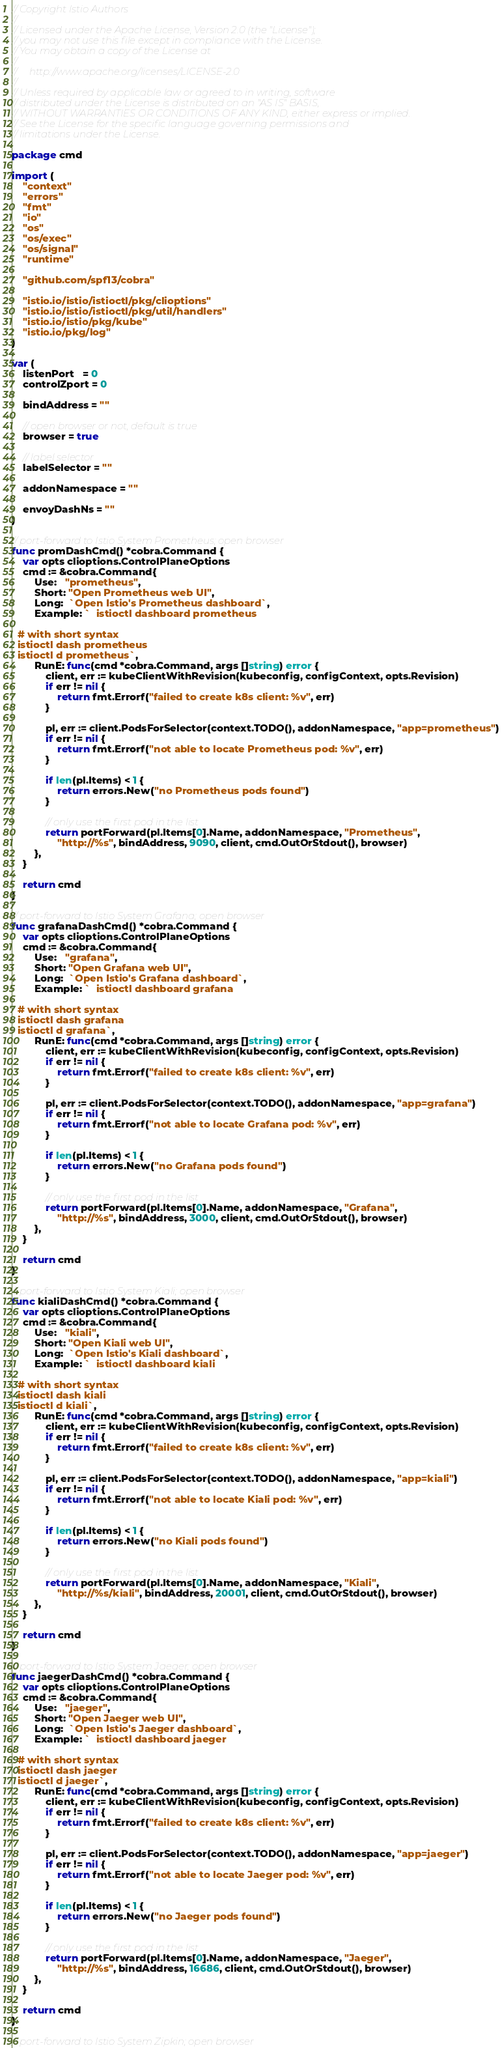<code> <loc_0><loc_0><loc_500><loc_500><_Go_>// Copyright Istio Authors
//
// Licensed under the Apache License, Version 2.0 (the "License");
// you may not use this file except in compliance with the License.
// You may obtain a copy of the License at
//
//     http://www.apache.org/licenses/LICENSE-2.0
//
// Unless required by applicable law or agreed to in writing, software
// distributed under the License is distributed on an "AS IS" BASIS,
// WITHOUT WARRANTIES OR CONDITIONS OF ANY KIND, either express or implied.
// See the License for the specific language governing permissions and
// limitations under the License.

package cmd

import (
	"context"
	"errors"
	"fmt"
	"io"
	"os"
	"os/exec"
	"os/signal"
	"runtime"

	"github.com/spf13/cobra"

	"istio.io/istio/istioctl/pkg/clioptions"
	"istio.io/istio/istioctl/pkg/util/handlers"
	"istio.io/istio/pkg/kube"
	"istio.io/pkg/log"
)

var (
	listenPort   = 0
	controlZport = 0

	bindAddress = ""

	// open browser or not, default is true
	browser = true

	// label selector
	labelSelector = ""

	addonNamespace = ""

	envoyDashNs = ""
)

// port-forward to Istio System Prometheus; open browser
func promDashCmd() *cobra.Command {
	var opts clioptions.ControlPlaneOptions
	cmd := &cobra.Command{
		Use:   "prometheus",
		Short: "Open Prometheus web UI",
		Long:  `Open Istio's Prometheus dashboard`,
		Example: `  istioctl dashboard prometheus

  # with short syntax
  istioctl dash prometheus
  istioctl d prometheus`,
		RunE: func(cmd *cobra.Command, args []string) error {
			client, err := kubeClientWithRevision(kubeconfig, configContext, opts.Revision)
			if err != nil {
				return fmt.Errorf("failed to create k8s client: %v", err)
			}

			pl, err := client.PodsForSelector(context.TODO(), addonNamespace, "app=prometheus")
			if err != nil {
				return fmt.Errorf("not able to locate Prometheus pod: %v", err)
			}

			if len(pl.Items) < 1 {
				return errors.New("no Prometheus pods found")
			}

			// only use the first pod in the list
			return portForward(pl.Items[0].Name, addonNamespace, "Prometheus",
				"http://%s", bindAddress, 9090, client, cmd.OutOrStdout(), browser)
		},
	}

	return cmd
}

// port-forward to Istio System Grafana; open browser
func grafanaDashCmd() *cobra.Command {
	var opts clioptions.ControlPlaneOptions
	cmd := &cobra.Command{
		Use:   "grafana",
		Short: "Open Grafana web UI",
		Long:  `Open Istio's Grafana dashboard`,
		Example: `  istioctl dashboard grafana

  # with short syntax
  istioctl dash grafana
  istioctl d grafana`,
		RunE: func(cmd *cobra.Command, args []string) error {
			client, err := kubeClientWithRevision(kubeconfig, configContext, opts.Revision)
			if err != nil {
				return fmt.Errorf("failed to create k8s client: %v", err)
			}

			pl, err := client.PodsForSelector(context.TODO(), addonNamespace, "app=grafana")
			if err != nil {
				return fmt.Errorf("not able to locate Grafana pod: %v", err)
			}

			if len(pl.Items) < 1 {
				return errors.New("no Grafana pods found")
			}

			// only use the first pod in the list
			return portForward(pl.Items[0].Name, addonNamespace, "Grafana",
				"http://%s", bindAddress, 3000, client, cmd.OutOrStdout(), browser)
		},
	}

	return cmd
}

// port-forward to Istio System Kiali; open browser
func kialiDashCmd() *cobra.Command {
	var opts clioptions.ControlPlaneOptions
	cmd := &cobra.Command{
		Use:   "kiali",
		Short: "Open Kiali web UI",
		Long:  `Open Istio's Kiali dashboard`,
		Example: `  istioctl dashboard kiali

  # with short syntax
  istioctl dash kiali
  istioctl d kiali`,
		RunE: func(cmd *cobra.Command, args []string) error {
			client, err := kubeClientWithRevision(kubeconfig, configContext, opts.Revision)
			if err != nil {
				return fmt.Errorf("failed to create k8s client: %v", err)
			}

			pl, err := client.PodsForSelector(context.TODO(), addonNamespace, "app=kiali")
			if err != nil {
				return fmt.Errorf("not able to locate Kiali pod: %v", err)
			}

			if len(pl.Items) < 1 {
				return errors.New("no Kiali pods found")
			}

			// only use the first pod in the list
			return portForward(pl.Items[0].Name, addonNamespace, "Kiali",
				"http://%s/kiali", bindAddress, 20001, client, cmd.OutOrStdout(), browser)
		},
	}

	return cmd
}

// port-forward to Istio System Jaeger; open browser
func jaegerDashCmd() *cobra.Command {
	var opts clioptions.ControlPlaneOptions
	cmd := &cobra.Command{
		Use:   "jaeger",
		Short: "Open Jaeger web UI",
		Long:  `Open Istio's Jaeger dashboard`,
		Example: `  istioctl dashboard jaeger

  # with short syntax
  istioctl dash jaeger
  istioctl d jaeger`,
		RunE: func(cmd *cobra.Command, args []string) error {
			client, err := kubeClientWithRevision(kubeconfig, configContext, opts.Revision)
			if err != nil {
				return fmt.Errorf("failed to create k8s client: %v", err)
			}

			pl, err := client.PodsForSelector(context.TODO(), addonNamespace, "app=jaeger")
			if err != nil {
				return fmt.Errorf("not able to locate Jaeger pod: %v", err)
			}

			if len(pl.Items) < 1 {
				return errors.New("no Jaeger pods found")
			}

			// only use the first pod in the list
			return portForward(pl.Items[0].Name, addonNamespace, "Jaeger",
				"http://%s", bindAddress, 16686, client, cmd.OutOrStdout(), browser)
		},
	}

	return cmd
}

// port-forward to Istio System Zipkin; open browser</code> 